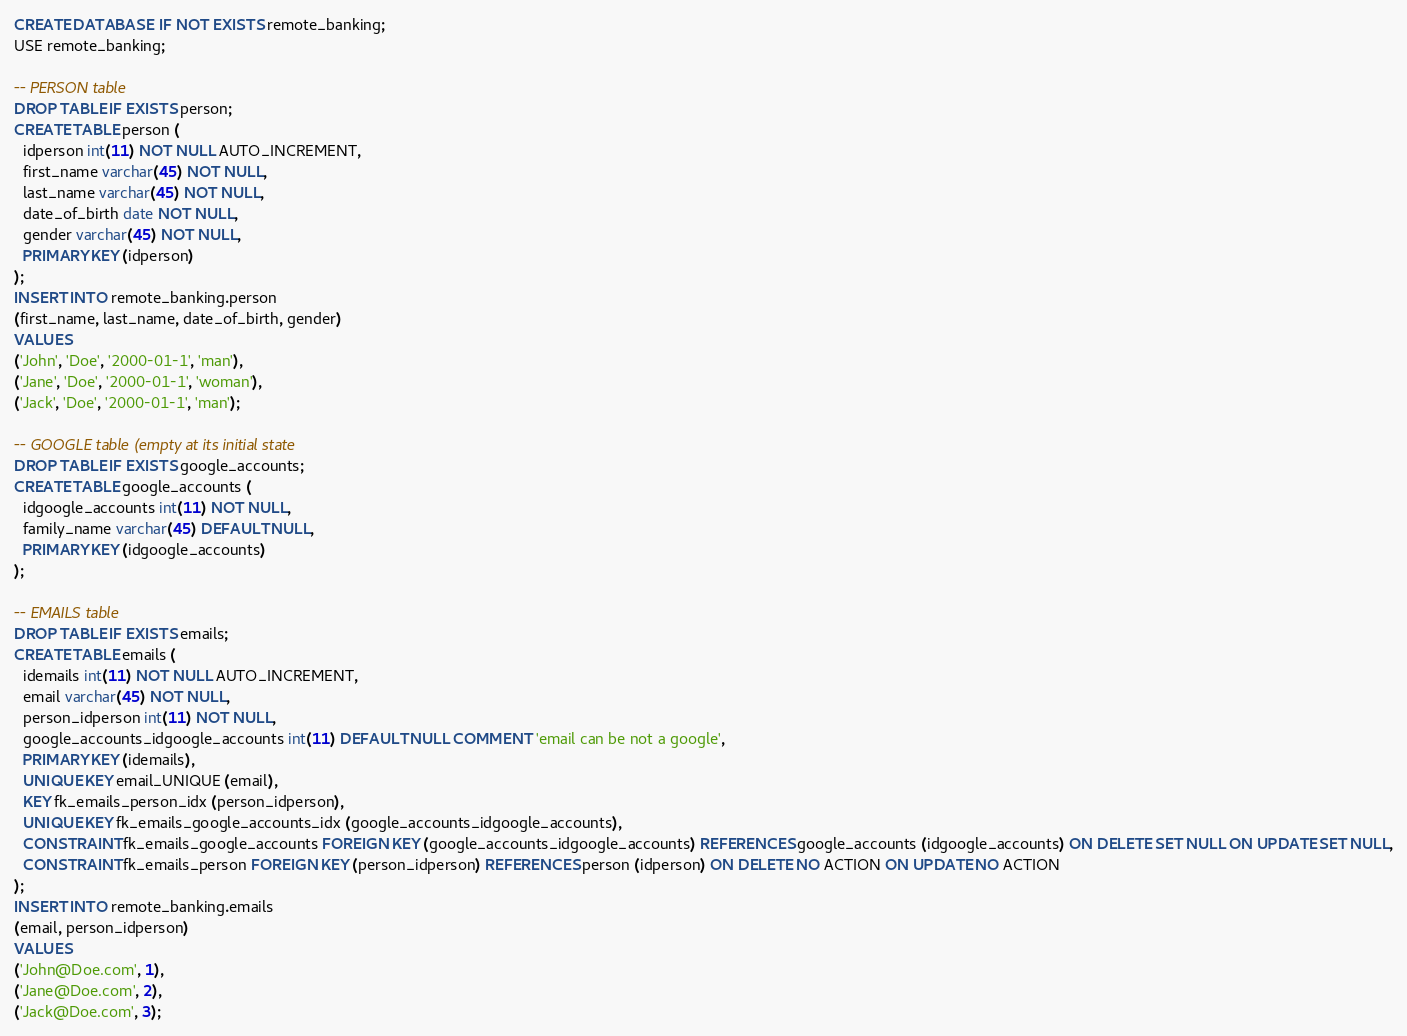Convert code to text. <code><loc_0><loc_0><loc_500><loc_500><_SQL_>CREATE DATABASE  IF NOT EXISTS remote_banking;
USE remote_banking;

-- PERSON table
DROP TABLE IF EXISTS person;
CREATE TABLE person (
  idperson int(11) NOT NULL AUTO_INCREMENT,
  first_name varchar(45) NOT NULL,
  last_name varchar(45) NOT NULL,
  date_of_birth date NOT NULL,
  gender varchar(45) NOT NULL,
  PRIMARY KEY (idperson)
);
INSERT INTO remote_banking.person
(first_name, last_name, date_of_birth, gender)
VALUES
('John', 'Doe', '2000-01-1', 'man'),
('Jane', 'Doe', '2000-01-1', 'woman'),
('Jack', 'Doe', '2000-01-1', 'man');

-- GOOGLE table (empty at its initial state
DROP TABLE IF EXISTS google_accounts;
CREATE TABLE google_accounts (
  idgoogle_accounts int(11) NOT NULL,
  family_name varchar(45) DEFAULT NULL,
  PRIMARY KEY (idgoogle_accounts)
);

-- EMAILS table
DROP TABLE IF EXISTS emails;
CREATE TABLE emails (
  idemails int(11) NOT NULL AUTO_INCREMENT,
  email varchar(45) NOT NULL,
  person_idperson int(11) NOT NULL,
  google_accounts_idgoogle_accounts int(11) DEFAULT NULL COMMENT 'email can be not a google',
  PRIMARY KEY (idemails),
  UNIQUE KEY email_UNIQUE (email),
  KEY fk_emails_person_idx (person_idperson),
  UNIQUE KEY fk_emails_google_accounts_idx (google_accounts_idgoogle_accounts),
  CONSTRAINT fk_emails_google_accounts FOREIGN KEY (google_accounts_idgoogle_accounts) REFERENCES google_accounts (idgoogle_accounts) ON DELETE SET NULL ON UPDATE SET NULL,
  CONSTRAINT fk_emails_person FOREIGN KEY (person_idperson) REFERENCES person (idperson) ON DELETE NO ACTION ON UPDATE NO ACTION
);
INSERT INTO remote_banking.emails
(email, person_idperson)
VALUES
('John@Doe.com', 1),
('Jane@Doe.com', 2),
('Jack@Doe.com', 3);
</code> 